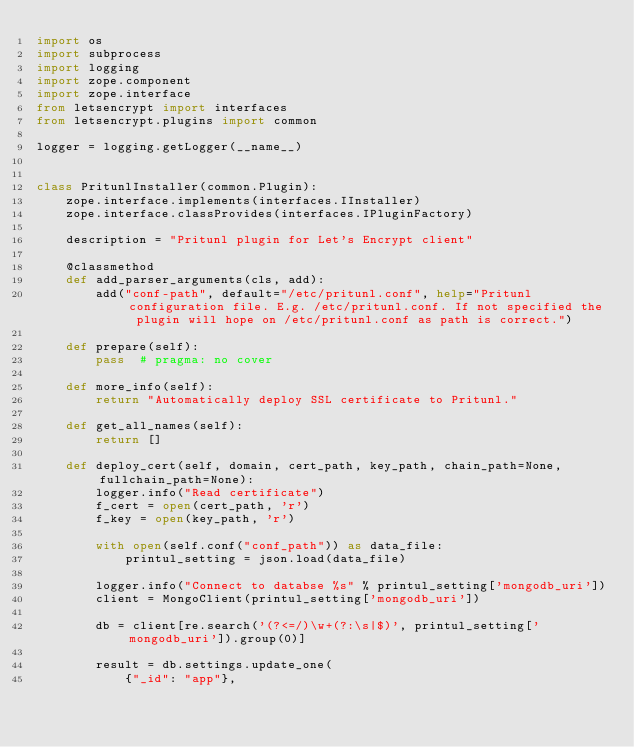<code> <loc_0><loc_0><loc_500><loc_500><_Python_>import os
import subprocess
import logging
import zope.component
import zope.interface
from letsencrypt import interfaces
from letsencrypt.plugins import common

logger = logging.getLogger(__name__)


class PritunlInstaller(common.Plugin):
    zope.interface.implements(interfaces.IInstaller)
    zope.interface.classProvides(interfaces.IPluginFactory)

    description = "Pritunl plugin for Let's Encrypt client"

    @classmethod
    def add_parser_arguments(cls, add):
        add("conf-path", default="/etc/pritunl.conf", help="Pritunl configuration file. E.g. /etc/pritunl.conf. If not specified the plugin will hope on /etc/pritunl.conf as path is correct.")

    def prepare(self):
        pass  # pragma: no cover

    def more_info(self):
        return "Automatically deploy SSL certificate to Pritunl."

    def get_all_names(self):
        return []

    def deploy_cert(self, domain, cert_path, key_path, chain_path=None, fullchain_path=None):
        logger.info("Read certificate")
        f_cert = open(cert_path, 'r')
        f_key = open(key_path, 'r')

        with open(self.conf("conf_path")) as data_file:
            printul_setting = json.load(data_file)

        logger.info("Connect to databse %s" % printul_setting['mongodb_uri'])
        client = MongoClient(printul_setting['mongodb_uri'])

        db = client[re.search('(?<=/)\w+(?:\s|$)', printul_setting['mongodb_uri']).group(0)]

        result = db.settings.update_one(
            {"_id": "app"},</code> 